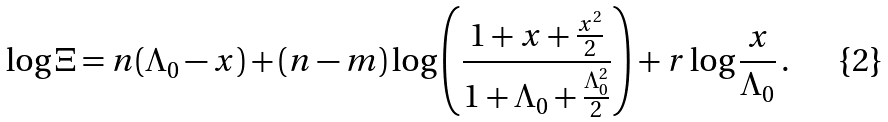<formula> <loc_0><loc_0><loc_500><loc_500>\log \Xi & = n ( \Lambda _ { 0 } - x ) + ( n - m ) \log \left ( \frac { 1 + x + \frac { x ^ { 2 } } 2 } { 1 + \Lambda _ { 0 } + \frac { \Lambda _ { 0 } ^ { 2 } } 2 } \right ) + r \log \frac { x } { \Lambda _ { 0 } } \, .</formula> 